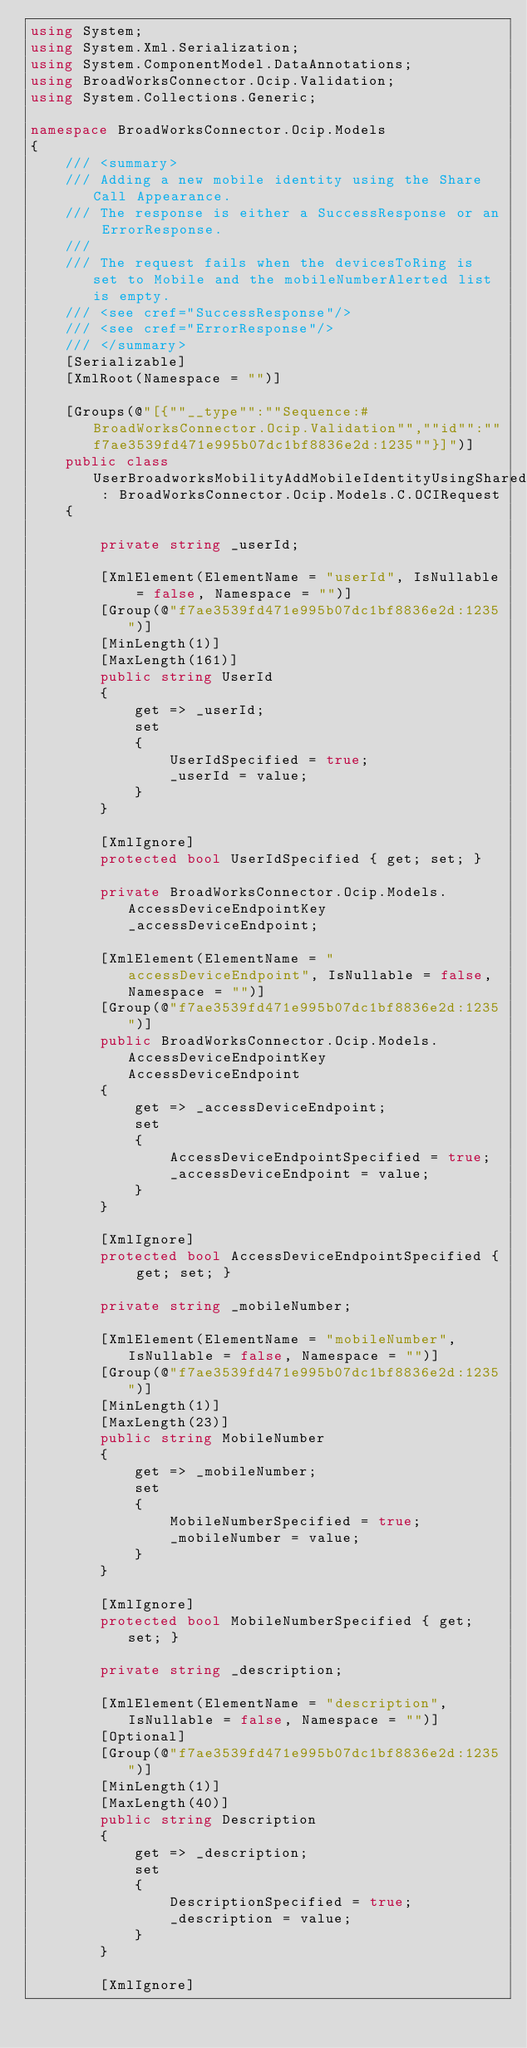<code> <loc_0><loc_0><loc_500><loc_500><_C#_>using System;
using System.Xml.Serialization;
using System.ComponentModel.DataAnnotations;
using BroadWorksConnector.Ocip.Validation;
using System.Collections.Generic;

namespace BroadWorksConnector.Ocip.Models
{
    /// <summary>
    /// Adding a new mobile identity using the Share Call Appearance.
    /// The response is either a SuccessResponse or an ErrorResponse.
    /// 
    /// The request fails when the devicesToRing is set to Mobile and the mobileNumberAlerted list is empty.
    /// <see cref="SuccessResponse"/>
    /// <see cref="ErrorResponse"/>
    /// </summary>
    [Serializable]
    [XmlRoot(Namespace = "")]

    [Groups(@"[{""__type"":""Sequence:#BroadWorksConnector.Ocip.Validation"",""id"":""f7ae3539fd471e995b07dc1bf8836e2d:1235""}]")]
    public class UserBroadworksMobilityAddMobileIdentityUsingSharedCallAppearanceRequest : BroadWorksConnector.Ocip.Models.C.OCIRequest
    {

        private string _userId;

        [XmlElement(ElementName = "userId", IsNullable = false, Namespace = "")]
        [Group(@"f7ae3539fd471e995b07dc1bf8836e2d:1235")]
        [MinLength(1)]
        [MaxLength(161)]
        public string UserId
        {
            get => _userId;
            set
            {
                UserIdSpecified = true;
                _userId = value;
            }
        }

        [XmlIgnore]
        protected bool UserIdSpecified { get; set; }

        private BroadWorksConnector.Ocip.Models.AccessDeviceEndpointKey _accessDeviceEndpoint;

        [XmlElement(ElementName = "accessDeviceEndpoint", IsNullable = false, Namespace = "")]
        [Group(@"f7ae3539fd471e995b07dc1bf8836e2d:1235")]
        public BroadWorksConnector.Ocip.Models.AccessDeviceEndpointKey AccessDeviceEndpoint
        {
            get => _accessDeviceEndpoint;
            set
            {
                AccessDeviceEndpointSpecified = true;
                _accessDeviceEndpoint = value;
            }
        }

        [XmlIgnore]
        protected bool AccessDeviceEndpointSpecified { get; set; }

        private string _mobileNumber;

        [XmlElement(ElementName = "mobileNumber", IsNullable = false, Namespace = "")]
        [Group(@"f7ae3539fd471e995b07dc1bf8836e2d:1235")]
        [MinLength(1)]
        [MaxLength(23)]
        public string MobileNumber
        {
            get => _mobileNumber;
            set
            {
                MobileNumberSpecified = true;
                _mobileNumber = value;
            }
        }

        [XmlIgnore]
        protected bool MobileNumberSpecified { get; set; }

        private string _description;

        [XmlElement(ElementName = "description", IsNullable = false, Namespace = "")]
        [Optional]
        [Group(@"f7ae3539fd471e995b07dc1bf8836e2d:1235")]
        [MinLength(1)]
        [MaxLength(40)]
        public string Description
        {
            get => _description;
            set
            {
                DescriptionSpecified = true;
                _description = value;
            }
        }

        [XmlIgnore]</code> 